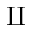Convert formula to latex. <formula><loc_0><loc_0><loc_500><loc_500>\amalg</formula> 